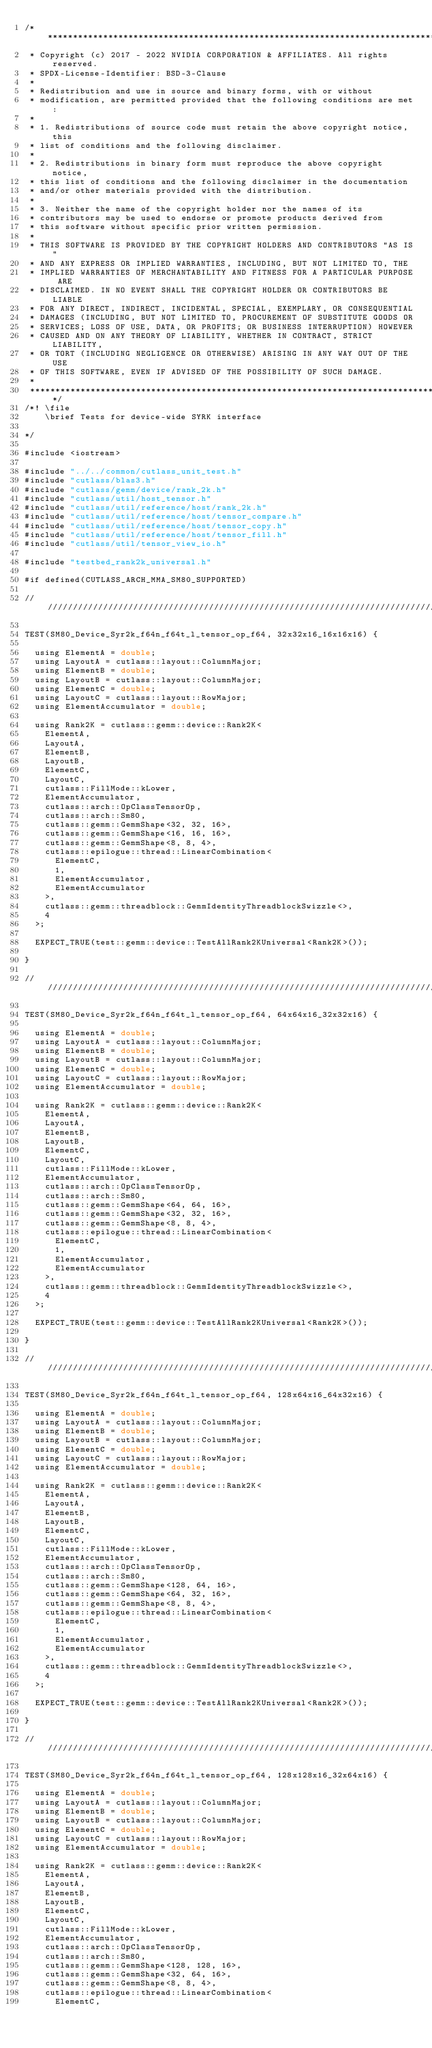Convert code to text. <code><loc_0><loc_0><loc_500><loc_500><_Cuda_>/***************************************************************************************************
 * Copyright (c) 2017 - 2022 NVIDIA CORPORATION & AFFILIATES. All rights reserved.
 * SPDX-License-Identifier: BSD-3-Clause
 *
 * Redistribution and use in source and binary forms, with or without
 * modification, are permitted provided that the following conditions are met:
 *
 * 1. Redistributions of source code must retain the above copyright notice, this
 * list of conditions and the following disclaimer.
 *
 * 2. Redistributions in binary form must reproduce the above copyright notice,
 * this list of conditions and the following disclaimer in the documentation
 * and/or other materials provided with the distribution.
 *
 * 3. Neither the name of the copyright holder nor the names of its
 * contributors may be used to endorse or promote products derived from
 * this software without specific prior written permission.
 *
 * THIS SOFTWARE IS PROVIDED BY THE COPYRIGHT HOLDERS AND CONTRIBUTORS "AS IS"
 * AND ANY EXPRESS OR IMPLIED WARRANTIES, INCLUDING, BUT NOT LIMITED TO, THE
 * IMPLIED WARRANTIES OF MERCHANTABILITY AND FITNESS FOR A PARTICULAR PURPOSE ARE
 * DISCLAIMED. IN NO EVENT SHALL THE COPYRIGHT HOLDER OR CONTRIBUTORS BE LIABLE
 * FOR ANY DIRECT, INDIRECT, INCIDENTAL, SPECIAL, EXEMPLARY, OR CONSEQUENTIAL
 * DAMAGES (INCLUDING, BUT NOT LIMITED TO, PROCUREMENT OF SUBSTITUTE GOODS OR
 * SERVICES; LOSS OF USE, DATA, OR PROFITS; OR BUSINESS INTERRUPTION) HOWEVER
 * CAUSED AND ON ANY THEORY OF LIABILITY, WHETHER IN CONTRACT, STRICT LIABILITY,
 * OR TORT (INCLUDING NEGLIGENCE OR OTHERWISE) ARISING IN ANY WAY OUT OF THE USE
 * OF THIS SOFTWARE, EVEN IF ADVISED OF THE POSSIBILITY OF SUCH DAMAGE.
 *
 **************************************************************************************************/
/*! \file
    \brief Tests for device-wide SYRK interface
  
*/

#include <iostream>

#include "../../common/cutlass_unit_test.h"
#include "cutlass/blas3.h"
#include "cutlass/gemm/device/rank_2k.h"
#include "cutlass/util/host_tensor.h"
#include "cutlass/util/reference/host/rank_2k.h"
#include "cutlass/util/reference/host/tensor_compare.h"
#include "cutlass/util/reference/host/tensor_copy.h"
#include "cutlass/util/reference/host/tensor_fill.h"
#include "cutlass/util/tensor_view_io.h"

#include "testbed_rank2k_universal.h"

#if defined(CUTLASS_ARCH_MMA_SM80_SUPPORTED)

/////////////////////////////////////////////////////////////////////////////////////////////////

TEST(SM80_Device_Syr2k_f64n_f64t_l_tensor_op_f64, 32x32x16_16x16x16) {

  using ElementA = double;
  using LayoutA = cutlass::layout::ColumnMajor;
  using ElementB = double;
  using LayoutB = cutlass::layout::ColumnMajor;
  using ElementC = double;
  using LayoutC = cutlass::layout::RowMajor;
  using ElementAccumulator = double;

  using Rank2K = cutlass::gemm::device::Rank2K<
    ElementA,
    LayoutA,
    ElementB,
    LayoutB,
    ElementC,
    LayoutC,
    cutlass::FillMode::kLower,
    ElementAccumulator,
    cutlass::arch::OpClassTensorOp,
    cutlass::arch::Sm80,
    cutlass::gemm::GemmShape<32, 32, 16>,
    cutlass::gemm::GemmShape<16, 16, 16>,
    cutlass::gemm::GemmShape<8, 8, 4>,
    cutlass::epilogue::thread::LinearCombination<
      ElementC,
      1,
      ElementAccumulator,
      ElementAccumulator
    >,
    cutlass::gemm::threadblock::GemmIdentityThreadblockSwizzle<>,
    4
  >;

  EXPECT_TRUE(test::gemm::device::TestAllRank2KUniversal<Rank2K>());

}

/////////////////////////////////////////////////////////////////////////////////////////////////

TEST(SM80_Device_Syr2k_f64n_f64t_l_tensor_op_f64, 64x64x16_32x32x16) {

  using ElementA = double;
  using LayoutA = cutlass::layout::ColumnMajor;
  using ElementB = double;
  using LayoutB = cutlass::layout::ColumnMajor;
  using ElementC = double;
  using LayoutC = cutlass::layout::RowMajor;
  using ElementAccumulator = double;

  using Rank2K = cutlass::gemm::device::Rank2K<
    ElementA,
    LayoutA,
    ElementB,
    LayoutB,
    ElementC,
    LayoutC,
    cutlass::FillMode::kLower,
    ElementAccumulator,
    cutlass::arch::OpClassTensorOp,
    cutlass::arch::Sm80,
    cutlass::gemm::GemmShape<64, 64, 16>,
    cutlass::gemm::GemmShape<32, 32, 16>,
    cutlass::gemm::GemmShape<8, 8, 4>,
    cutlass::epilogue::thread::LinearCombination<
      ElementC,
      1,
      ElementAccumulator,
      ElementAccumulator
    >,
    cutlass::gemm::threadblock::GemmIdentityThreadblockSwizzle<>,
    4
  >;

  EXPECT_TRUE(test::gemm::device::TestAllRank2KUniversal<Rank2K>());

}

/////////////////////////////////////////////////////////////////////////////////////////////////

TEST(SM80_Device_Syr2k_f64n_f64t_l_tensor_op_f64, 128x64x16_64x32x16) {

  using ElementA = double;
  using LayoutA = cutlass::layout::ColumnMajor;
  using ElementB = double;
  using LayoutB = cutlass::layout::ColumnMajor;
  using ElementC = double;
  using LayoutC = cutlass::layout::RowMajor;
  using ElementAccumulator = double;

  using Rank2K = cutlass::gemm::device::Rank2K<
    ElementA,
    LayoutA,
    ElementB,
    LayoutB,
    ElementC,
    LayoutC,
    cutlass::FillMode::kLower,
    ElementAccumulator,
    cutlass::arch::OpClassTensorOp,
    cutlass::arch::Sm80,
    cutlass::gemm::GemmShape<128, 64, 16>,
    cutlass::gemm::GemmShape<64, 32, 16>,
    cutlass::gemm::GemmShape<8, 8, 4>,
    cutlass::epilogue::thread::LinearCombination<
      ElementC,
      1,
      ElementAccumulator,
      ElementAccumulator
    >,
    cutlass::gemm::threadblock::GemmIdentityThreadblockSwizzle<>,
    4
  >;

  EXPECT_TRUE(test::gemm::device::TestAllRank2KUniversal<Rank2K>());

}

/////////////////////////////////////////////////////////////////////////////////////////////////

TEST(SM80_Device_Syr2k_f64n_f64t_l_tensor_op_f64, 128x128x16_32x64x16) {

  using ElementA = double;
  using LayoutA = cutlass::layout::ColumnMajor;
  using ElementB = double;
  using LayoutB = cutlass::layout::ColumnMajor;
  using ElementC = double;
  using LayoutC = cutlass::layout::RowMajor;
  using ElementAccumulator = double;

  using Rank2K = cutlass::gemm::device::Rank2K<
    ElementA,
    LayoutA,
    ElementB,
    LayoutB,
    ElementC,
    LayoutC,
    cutlass::FillMode::kLower,
    ElementAccumulator,
    cutlass::arch::OpClassTensorOp,
    cutlass::arch::Sm80,
    cutlass::gemm::GemmShape<128, 128, 16>,
    cutlass::gemm::GemmShape<32, 64, 16>,
    cutlass::gemm::GemmShape<8, 8, 4>,
    cutlass::epilogue::thread::LinearCombination<
      ElementC,</code> 